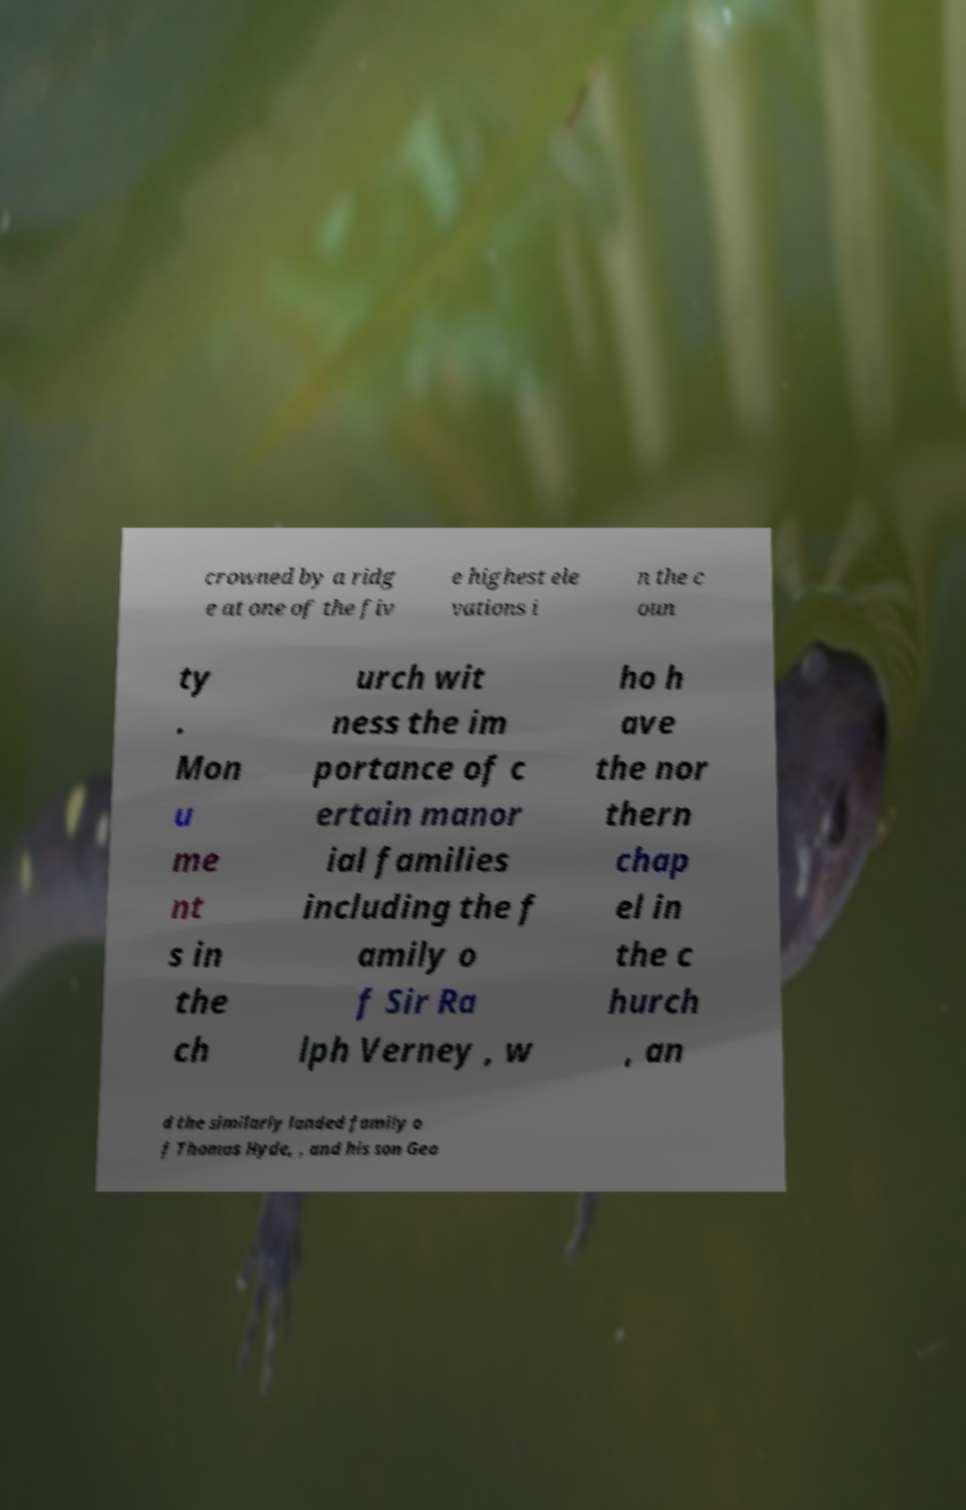Can you read and provide the text displayed in the image?This photo seems to have some interesting text. Can you extract and type it out for me? crowned by a ridg e at one of the fiv e highest ele vations i n the c oun ty . Mon u me nt s in the ch urch wit ness the im portance of c ertain manor ial families including the f amily o f Sir Ra lph Verney , w ho h ave the nor thern chap el in the c hurch , an d the similarly landed family o f Thomas Hyde, , and his son Geo 